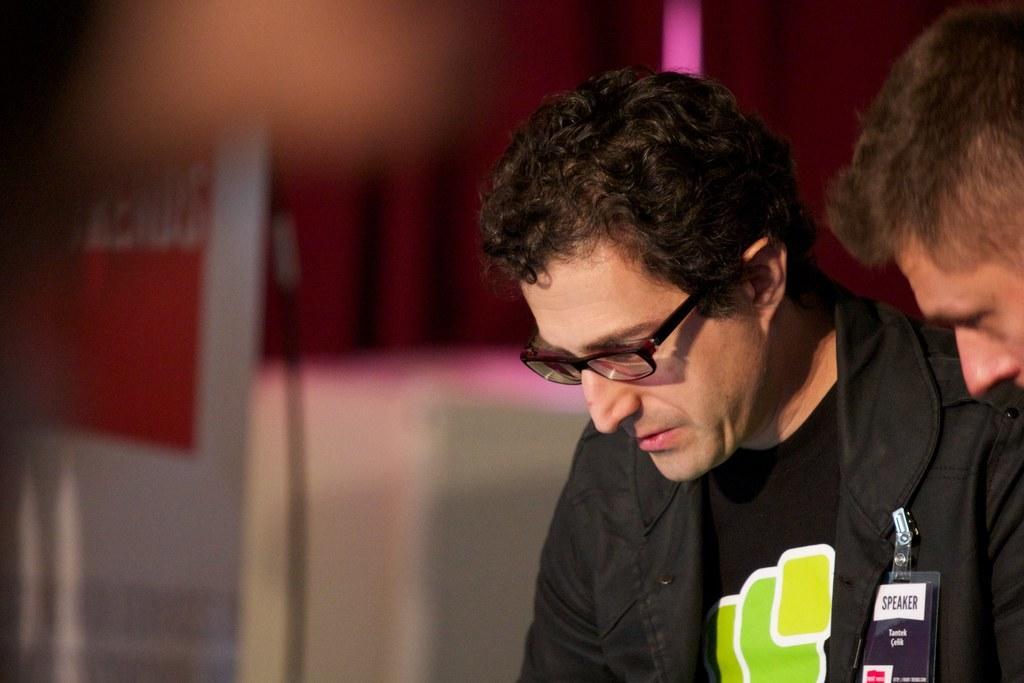Describe this image in one or two sentences. In this image I can see a person wearing black colored dress and black colored spectacles and another person's face to the right side of the image. I can see the blurry background in which I can see a banner which is white and orange in color and few other objects. 